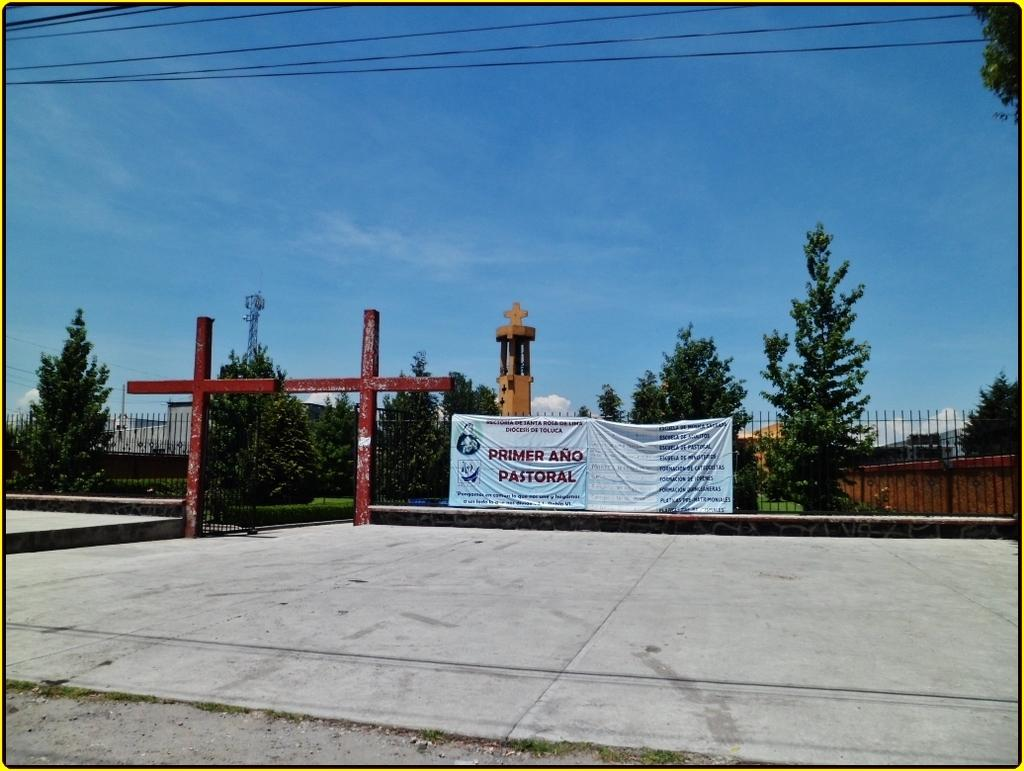What is: What is the main feature in the center of the image? There are banners at the center of the image. What can be seen in the background of the image? There is a pillar in the background of the image. What is on the right side of the image? There is a wall on the right side of the image. What is visible at the top of the image? The sky is visible at the top of the image. How many waves can be seen crashing against the wall in the image? There are no waves present in the image; it features banners, a pillar, a wall, and the sky. What type of insect is crawling on the banners in the image? There are no insects present on the banners in the image. 